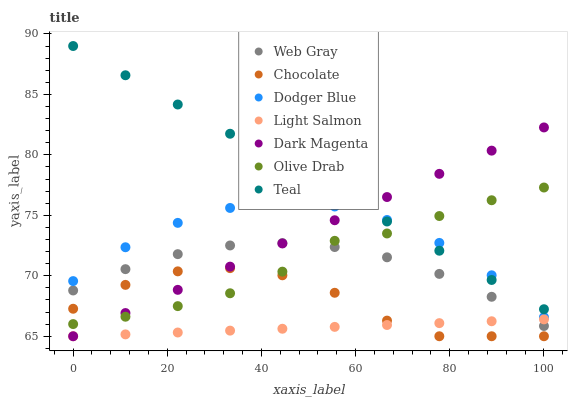Does Light Salmon have the minimum area under the curve?
Answer yes or no. Yes. Does Teal have the maximum area under the curve?
Answer yes or no. Yes. Does Web Gray have the minimum area under the curve?
Answer yes or no. No. Does Web Gray have the maximum area under the curve?
Answer yes or no. No. Is Teal the smoothest?
Answer yes or no. Yes. Is Chocolate the roughest?
Answer yes or no. Yes. Is Web Gray the smoothest?
Answer yes or no. No. Is Web Gray the roughest?
Answer yes or no. No. Does Light Salmon have the lowest value?
Answer yes or no. Yes. Does Web Gray have the lowest value?
Answer yes or no. No. Does Teal have the highest value?
Answer yes or no. Yes. Does Web Gray have the highest value?
Answer yes or no. No. Is Chocolate less than Teal?
Answer yes or no. Yes. Is Web Gray greater than Chocolate?
Answer yes or no. Yes. Does Web Gray intersect Olive Drab?
Answer yes or no. Yes. Is Web Gray less than Olive Drab?
Answer yes or no. No. Is Web Gray greater than Olive Drab?
Answer yes or no. No. Does Chocolate intersect Teal?
Answer yes or no. No. 